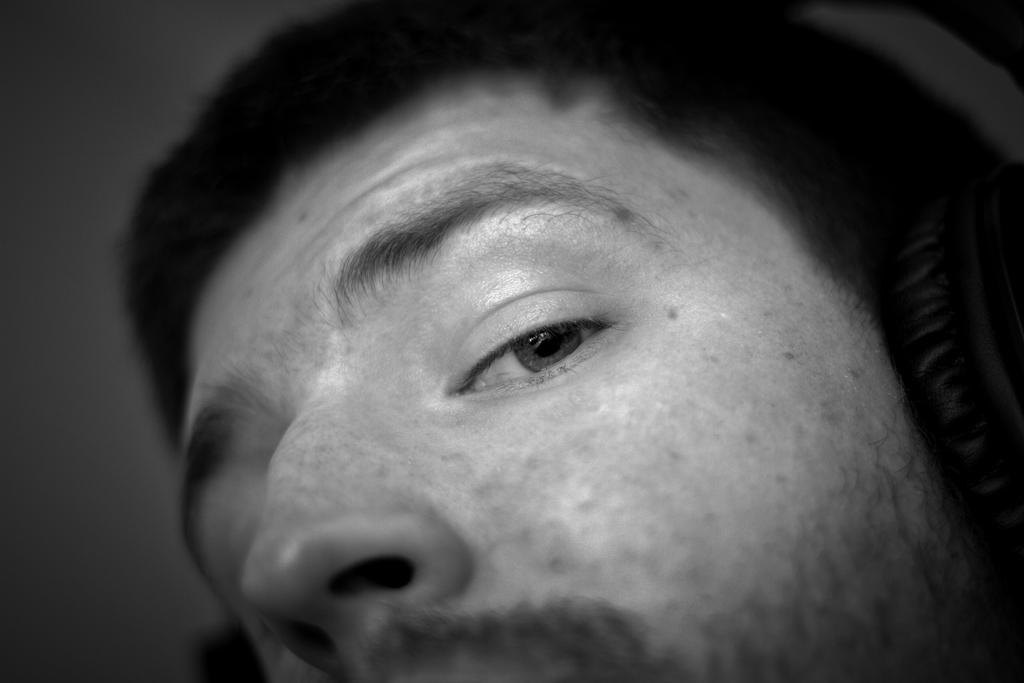What is the color scheme of the image? The image is black and white. What can be seen on the person's face in the image? There is a person's face visible in the image. What is the person wearing in the image? The person is wearing a headset in the image. How many bikes are parked next to the person in the image? There is no mention of bikes in the image, so it cannot be determined how many bikes might be present. What type of pest can be seen crawling on the person's face in the image? There is no pest visible on the person's face in the image. 